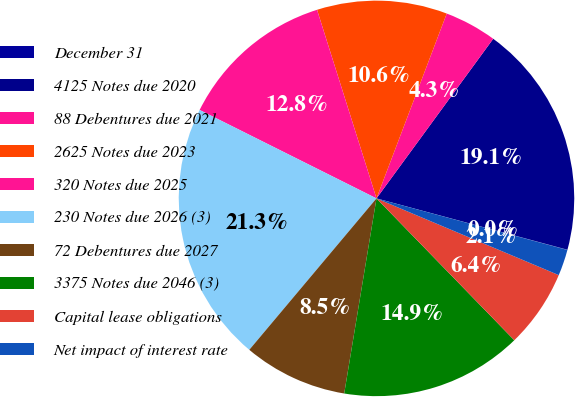Convert chart to OTSL. <chart><loc_0><loc_0><loc_500><loc_500><pie_chart><fcel>December 31<fcel>4125 Notes due 2020<fcel>88 Debentures due 2021<fcel>2625 Notes due 2023<fcel>320 Notes due 2025<fcel>230 Notes due 2026 (3)<fcel>72 Debentures due 2027<fcel>3375 Notes due 2046 (3)<fcel>Capital lease obligations<fcel>Net impact of interest rate<nl><fcel>0.02%<fcel>19.13%<fcel>4.27%<fcel>10.64%<fcel>12.76%<fcel>21.26%<fcel>8.51%<fcel>14.88%<fcel>6.39%<fcel>2.14%<nl></chart> 